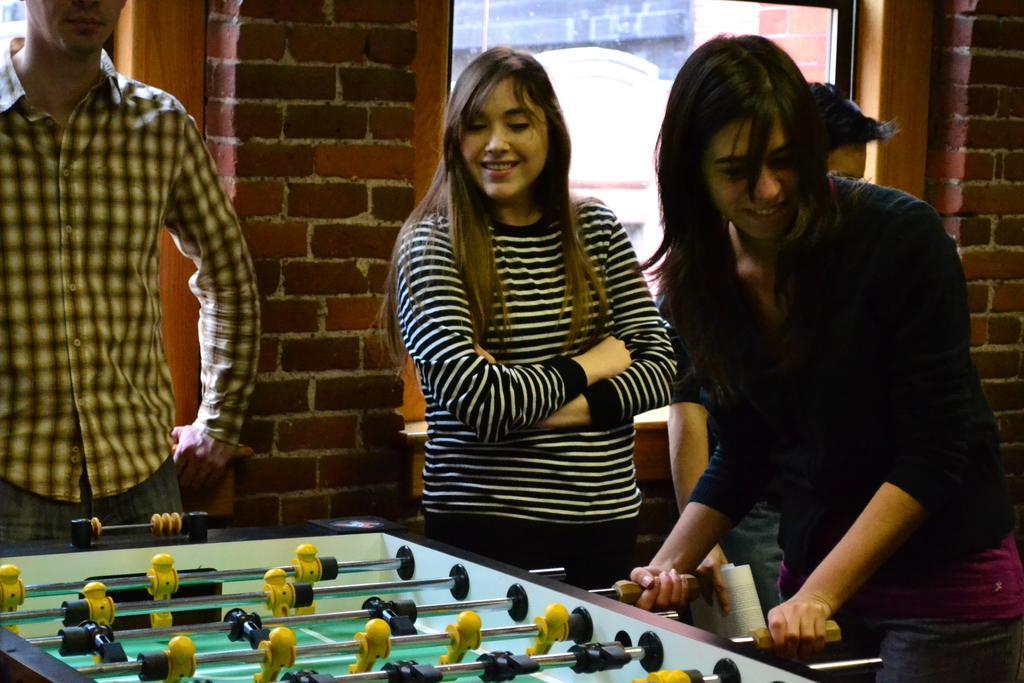Describe this image in one or two sentences. In this picture there are people standing, among them there is a woman playing a game. In the background of the image we can see bricks wall and glass window, through this glass window we can see wall. 